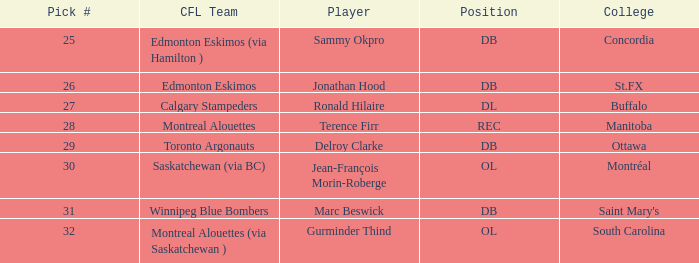What is the pick number for buffalo? 27.0. 